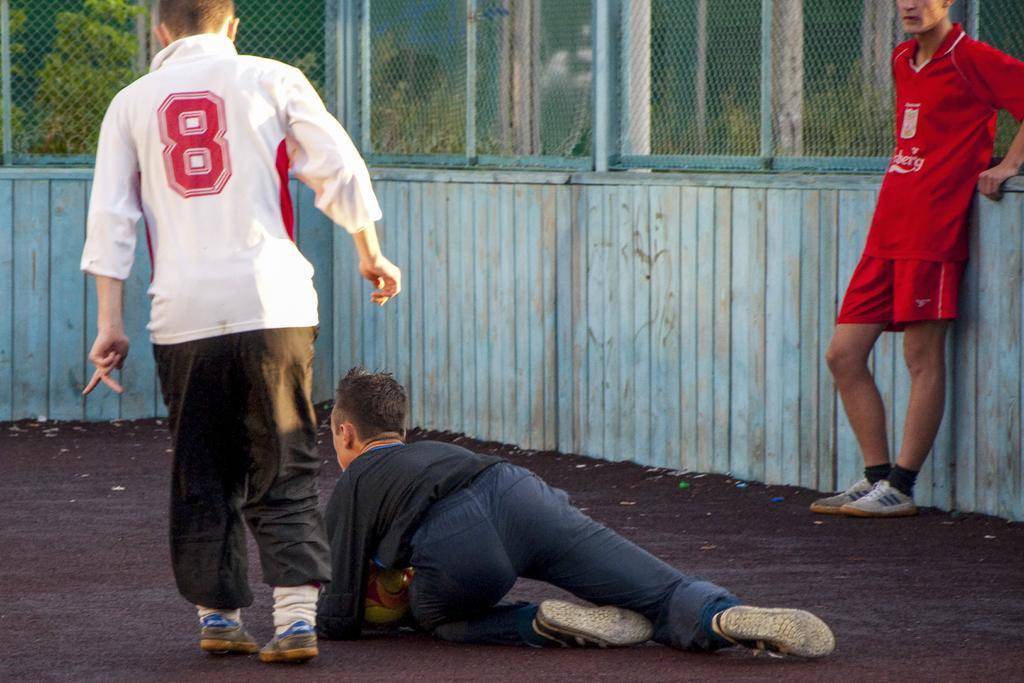How would you summarize this image in a sentence or two? In this image I see 3 boys in which this boy is wearing red jersey and this boy is wearing white and black dress and this boy is wearing black and blue dress and I see a ball over here and I see the ground and I see the fencing and I can also see the trees. 